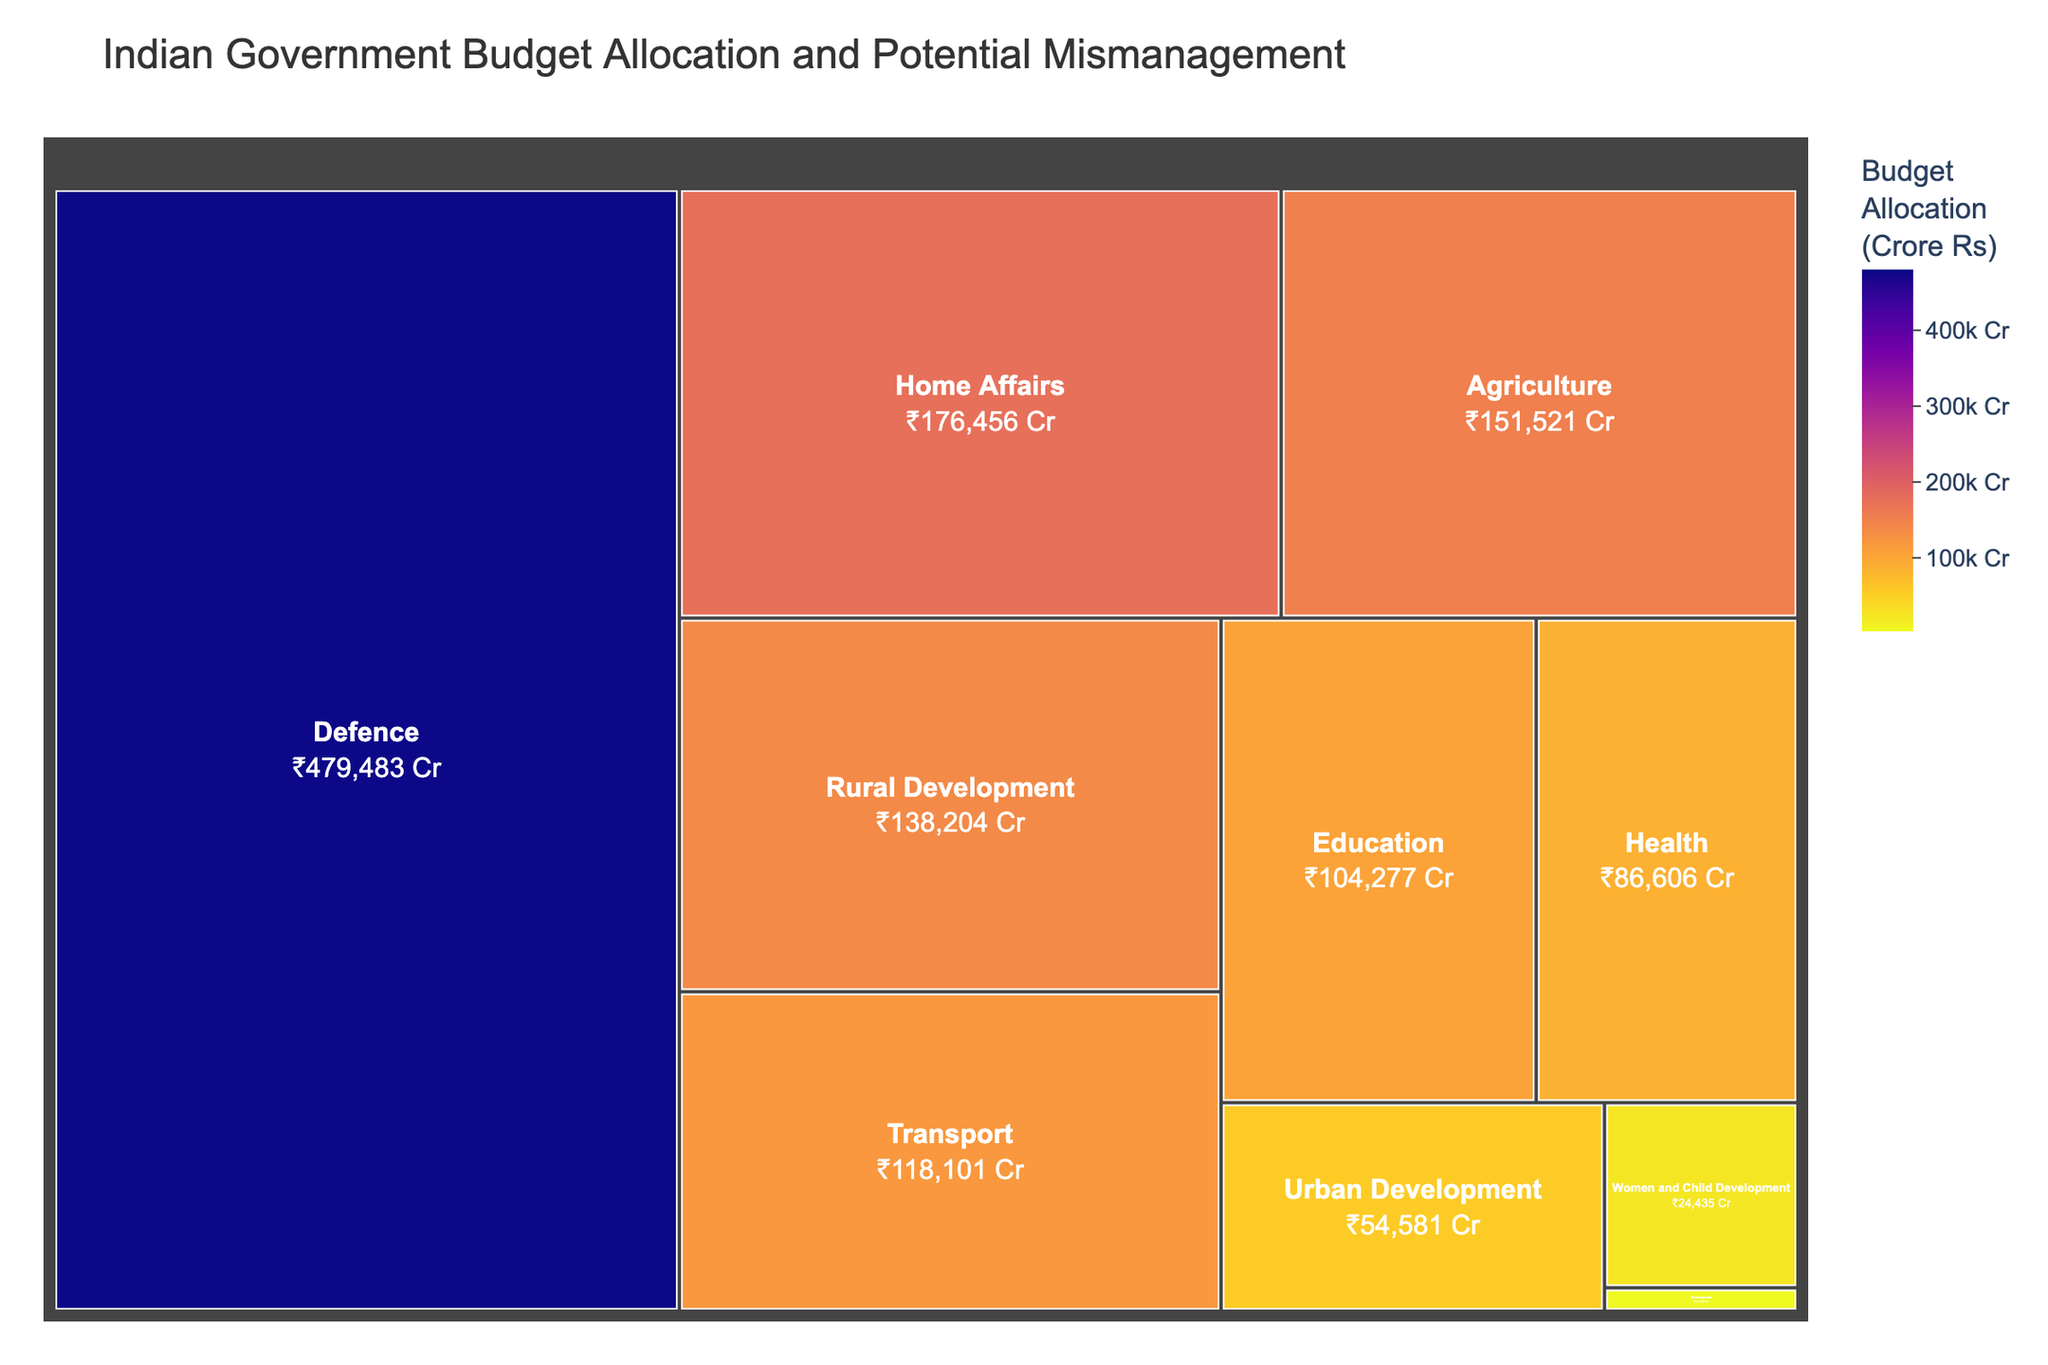What is the title of the treemap? The title is usually displayed at the top of the plot and provides an overview of what the figure represents. In this case, it is 'Indian Government Budget Allocation and Potential Mismanagement.'
Answer: Indian Government Budget Allocation and Potential Mismanagement Which ministry receives the highest budget allocation? By looking at the size of the blocks in the treemap and their labels, the largest block corresponds to the ministry with the highest budget allocation. The 'Defence' ministry has the largest block.
Answer: Defence What is the total budget allocation for the Health ministry? The size and color of the blocks represent the budget allocation, and the specific value is provided in the hover data. For the Health ministry, it shows ₹86,606 Crore.
Answer: ₹86,606 Crore Compare the budget allocation between the Home Affairs and the Education ministries. Comparing the sizes and values of the blocks, the Home Affairs ministry has a budget of ₹176,456 Crore, whereas the Education ministry has a budget of ₹104,277 Crore. Home Affairs receives more.
Answer: Home Affairs Which ministry is identified with the potential mismanagement of 'Delayed and over-budget infrastructure projects'? The label within the hover data indicates the potential mismanagement type. The 'Transport' ministry is associated with this issue.
Answer: Transport What is the combined budget allocation for the Agriculture and Rural Development ministries? Adding the budget allocations for both ministries, Agriculture has ₹151,521 Crore and Rural Development has ₹138,204 Crore. So, the combined budget is ₹151,521 + ₹138,204.
Answer: ₹289,725 Crore Which ministries have budget allocations below ₹50,000 Crore? Looking at the sizes and values of the blocks, Urban Development and Women and Child Development ministries have allocations below ₹50,000 Crore.
Answer: Urban Development, Women and Child Development Is the budget allocation for the Education ministry higher or lower than that of the Transport ministry? Comparing the blocks, the Education ministry (₹104,277 Crore) has a lower budget allocation compared to the Transport ministry (₹118,101 Crore).
Answer: Lower What is the potential mismanagement area for the Women and Child Development ministry? The hover data provides this information. The 'Women and Child Development' ministry is associated with 'Ineffective implementation of welfare schemes.'
Answer: Ineffective implementation of welfare schemes 